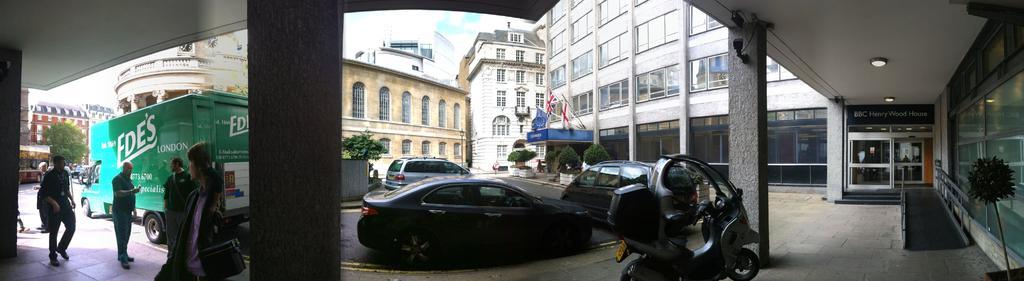In one or two sentences, can you explain what this image depicts? In this picture there are buildings and trees and there are vehicles on the road. On the left side of the image there are group of people walking. In the middle of the image there are flags and there is a board on the building. At the top there is sky and there are clouds. At the bottom there is a road. On the right side of the image there is a ramp and there is a handrail. 